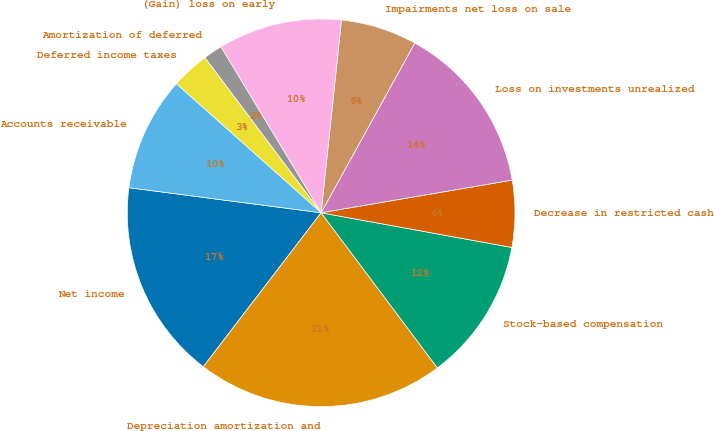Convert chart to OTSL. <chart><loc_0><loc_0><loc_500><loc_500><pie_chart><fcel>Net income<fcel>Depreciation amortization and<fcel>Stock-based compensation<fcel>Decrease in restricted cash<fcel>Loss on investments unrealized<fcel>Impairments net loss on sale<fcel>(Gain) loss on early<fcel>Amortization of deferred<fcel>Deferred income taxes<fcel>Accounts receivable<nl><fcel>16.67%<fcel>20.63%<fcel>11.9%<fcel>5.56%<fcel>14.28%<fcel>6.35%<fcel>10.32%<fcel>1.59%<fcel>3.18%<fcel>9.52%<nl></chart> 